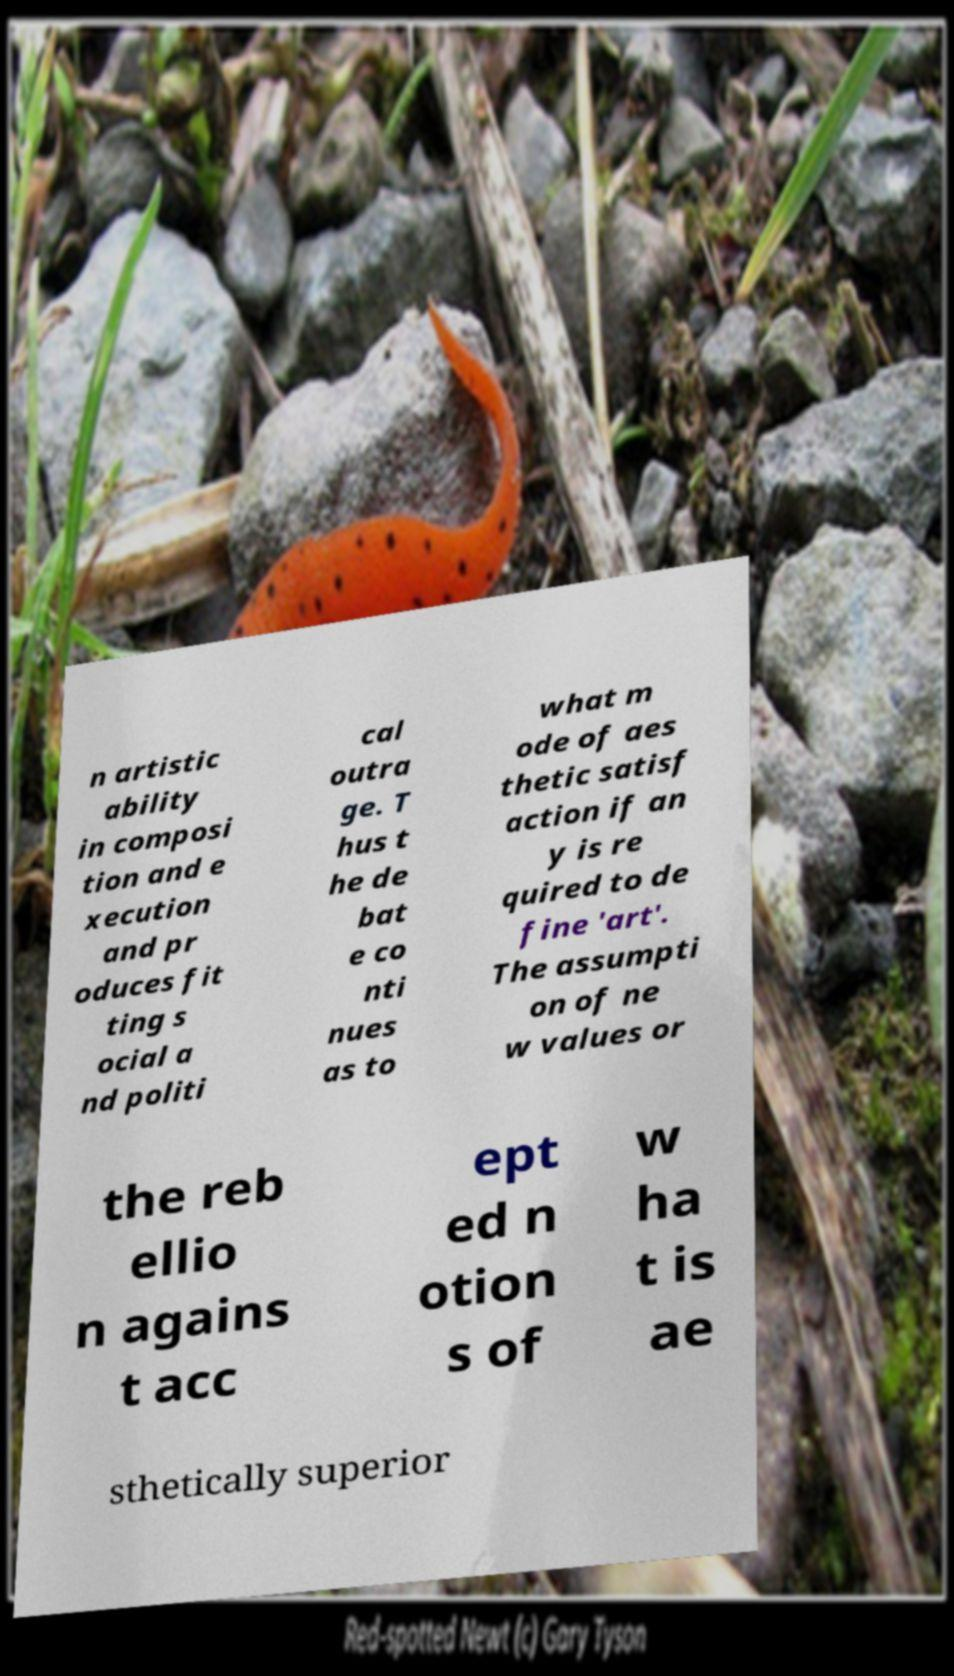There's text embedded in this image that I need extracted. Can you transcribe it verbatim? n artistic ability in composi tion and e xecution and pr oduces fit ting s ocial a nd politi cal outra ge. T hus t he de bat e co nti nues as to what m ode of aes thetic satisf action if an y is re quired to de fine 'art'. The assumpti on of ne w values or the reb ellio n agains t acc ept ed n otion s of w ha t is ae sthetically superior 